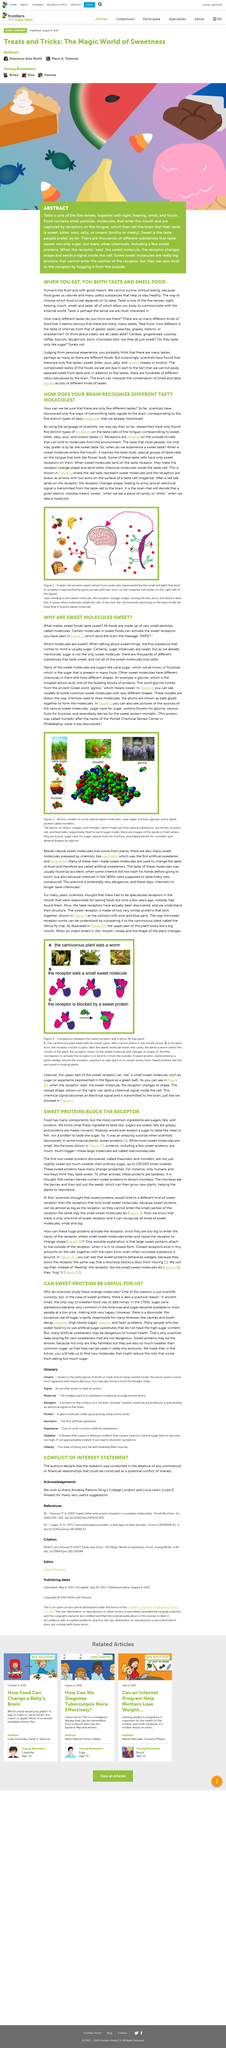List a handful of essential elements in this visual. Humans have five senses. When eating food, I use two of my five senses: taste and smell. Tropical plants produce sweet proteins that act as receptor blockers. The sweetness of molecules in sweet foods is caused by the activation of sweet receptors, which triggers the brain to perceive the taste as "sweet. The fact is that sugar molecules are indeed sweet. 